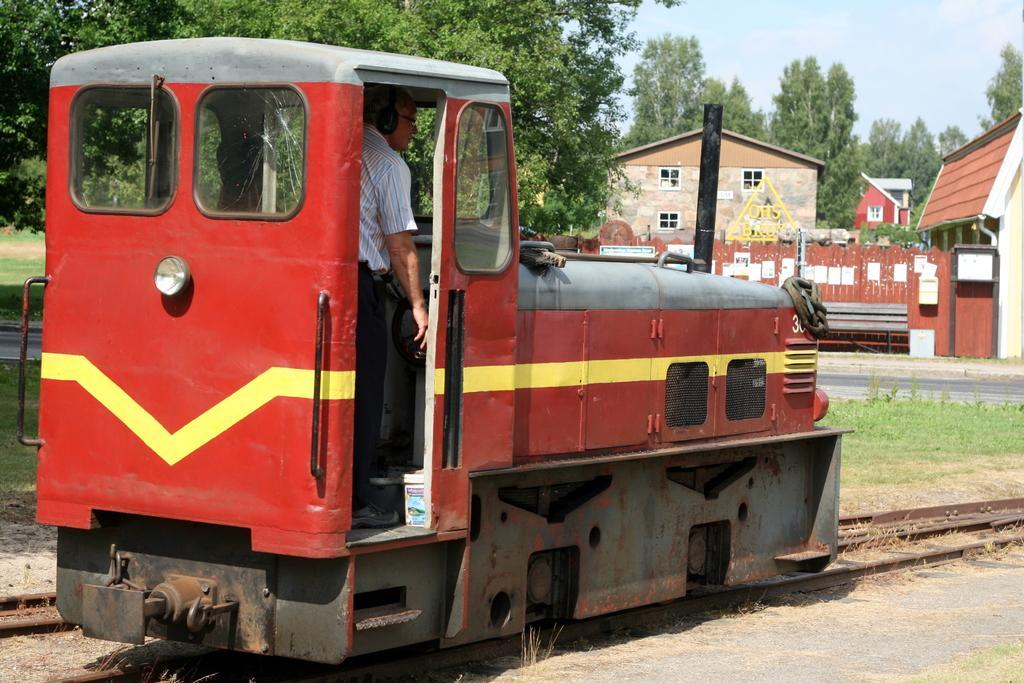Please provide a concise description of this image. In this image I can see a train engine which is maroon, yellow and grey in color on the railway track and I can see a person is standing in it. In the background I can see few trees which are green in color, few buildings, the ground and the sky. 